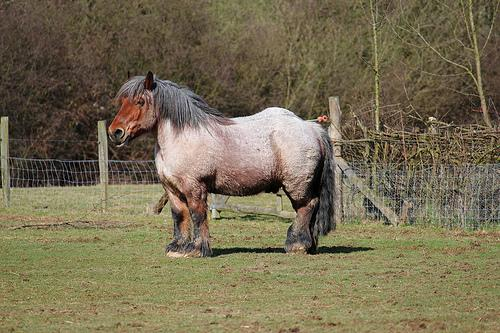Provide a holistic summary, covering the main and secondary elements in the image. An unusually large, heavy-looking workhorse stands on a grassy ground near a fence with tall posts. The horse, with its broad face, red head, and large snout, has thick brown and black legs, a grey mane, and a long tail. A dense forest serves as the image's background, accompanied by wire mesh fencing and a few dead branches. Does the image have a balance of quality and focus on the main subject? Yes, the image has a good focus on the horse, capturing its size and general features while still providing information about the surrounding environment. Determine the sentiment the image evokes and describe why. The image evokes a sense of strength and calmness due to the horse's stature and the serene forest background. Describe the background of the image, including any objects or scenery. The background features a dense forest, tall fence posts, and grass on the ground. There is also a mesh to the right, a dead branch, and wire mesh fencing. Some dead brambles can be seen as well. Count the number of fence posts and describe their appearance. There are four fence posts in the image, described as tall and made of brown wood. The edges of the fence can also be seen in some parts. What is the main subject of the image and what are its prominent features? The main subject of the image is a horse with a thick brown and black leg, grey mane, and long tail. The horse has a white body and a red face with a long black tail and black and gray mane. What type of horse is depicted in the image and what can be said about its size? The image depicts a sturdy, heavy-looking work horse that appears unusually large and stout. The horse looks larger than a normal steed and has a broad face. Analyze the interaction between the horse and the environment around it. The horse is standing on a grassy ground near a fence, with tall fence posts surrounding it. The horse casts a shadow, indicating it may be sunny. How would you describe the horse's facial and head features? The horse has a red face, a snout, two ears, and a left eye with a large left nostril. The head of the horse is brown. Identify the total number of legs in the image and describe them. There are four thick legs visible in the image, all belonging to the horse. They are brown and black in color. The green bird perched on the fence post is looking at the horse. No, it's not mentioned in the image. 